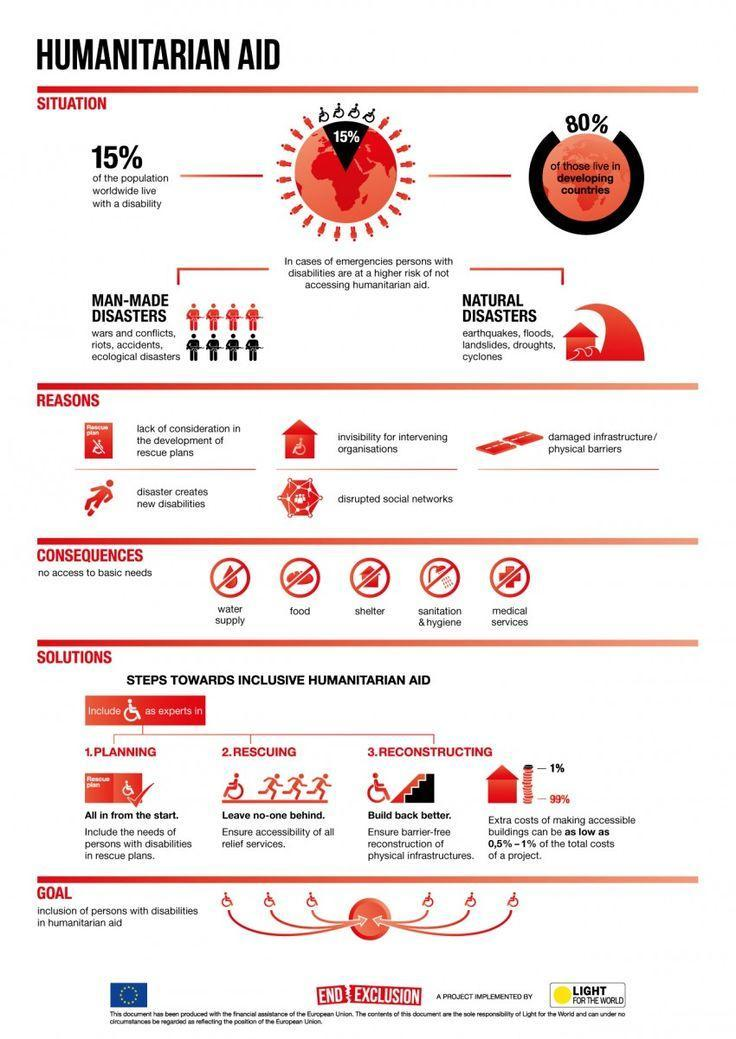What are the two types of disasters?
Answer the question with a short phrase. Man-made disasters, Natural disasters What is the percentage of people with disabilities living in developed countries? 20% 